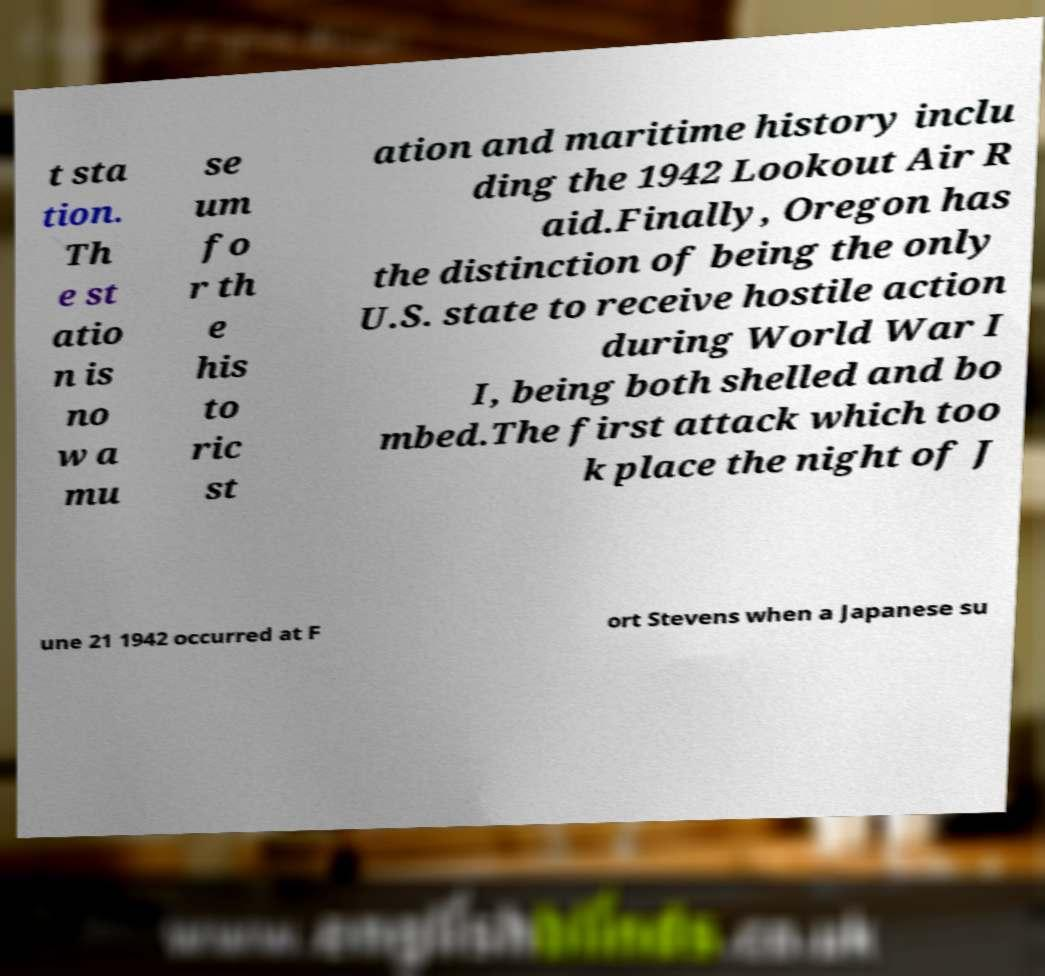What messages or text are displayed in this image? I need them in a readable, typed format. t sta tion. Th e st atio n is no w a mu se um fo r th e his to ric st ation and maritime history inclu ding the 1942 Lookout Air R aid.Finally, Oregon has the distinction of being the only U.S. state to receive hostile action during World War I I, being both shelled and bo mbed.The first attack which too k place the night of J une 21 1942 occurred at F ort Stevens when a Japanese su 